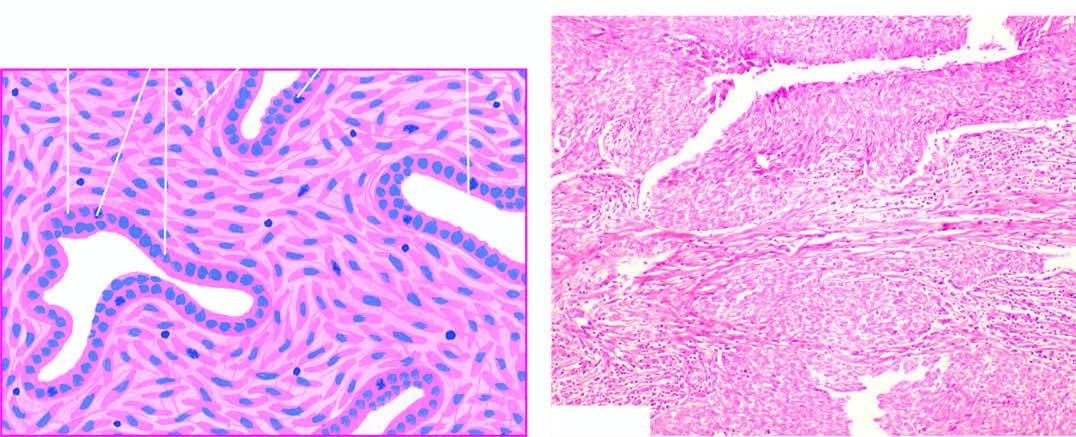s the tumour composed of epithelial-like cells lining cleft-like spaces and gland-like structures?
Answer the question using a single word or phrase. Yes 